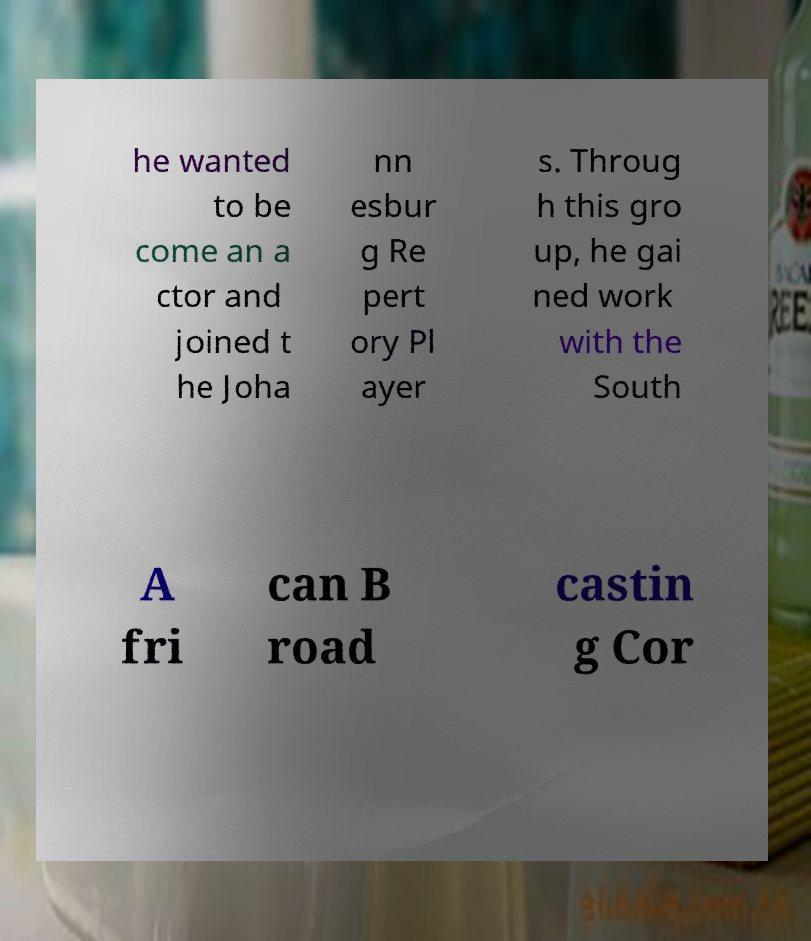Please read and relay the text visible in this image. What does it say? he wanted to be come an a ctor and joined t he Joha nn esbur g Re pert ory Pl ayer s. Throug h this gro up, he gai ned work with the South A fri can B road castin g Cor 